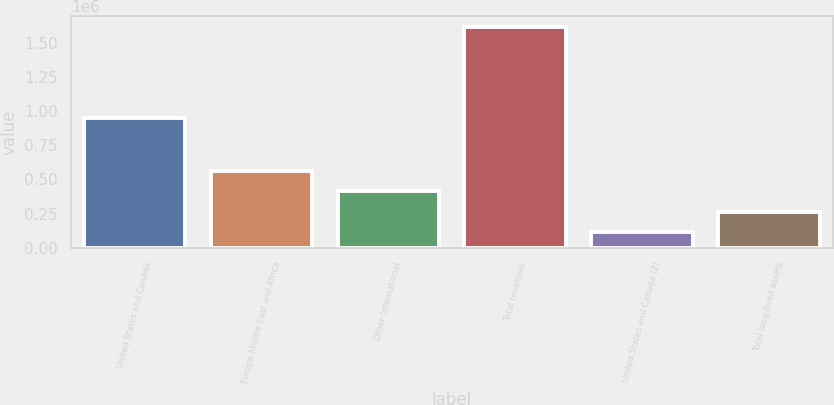Convert chart. <chart><loc_0><loc_0><loc_500><loc_500><bar_chart><fcel>United States and Canada<fcel>Europe Middle East and Africa<fcel>Other International<fcel>Total revenues<fcel>United States and Canada (2)<fcel>Total long-lived assets<nl><fcel>947075<fcel>564932<fcel>414807<fcel>1.61581e+06<fcel>114557<fcel>264682<nl></chart> 